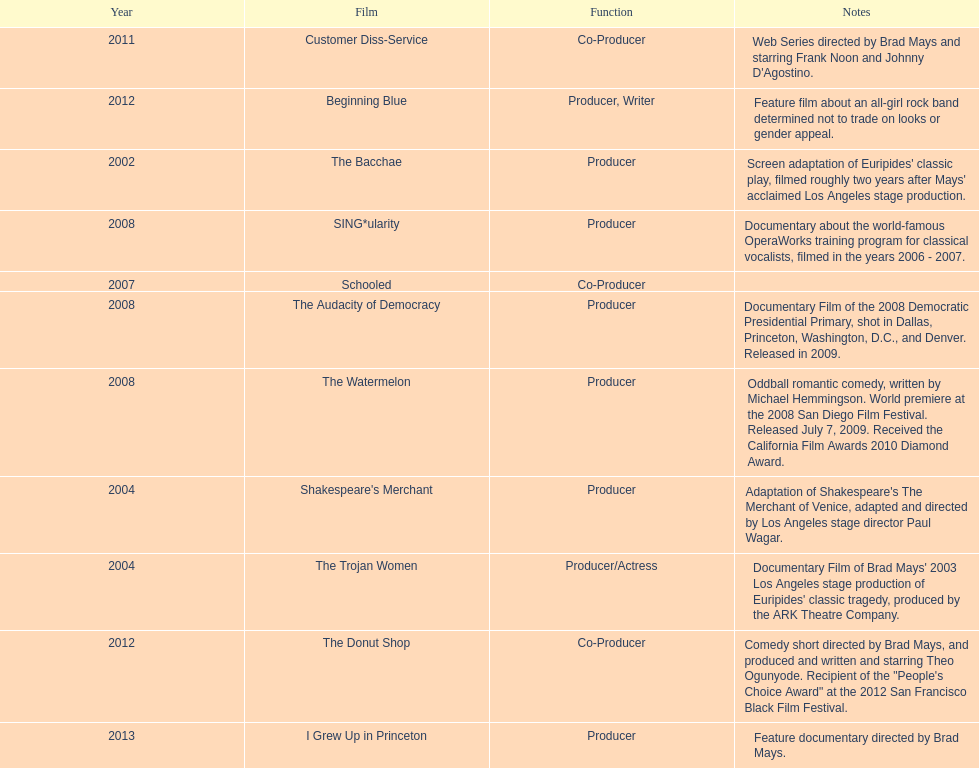How many films did ms. starfelt produce after 2010? 4. 